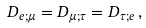<formula> <loc_0><loc_0><loc_500><loc_500>D _ { e ; \mu } = D _ { \mu ; \tau } = D _ { \tau ; e } \, ,</formula> 